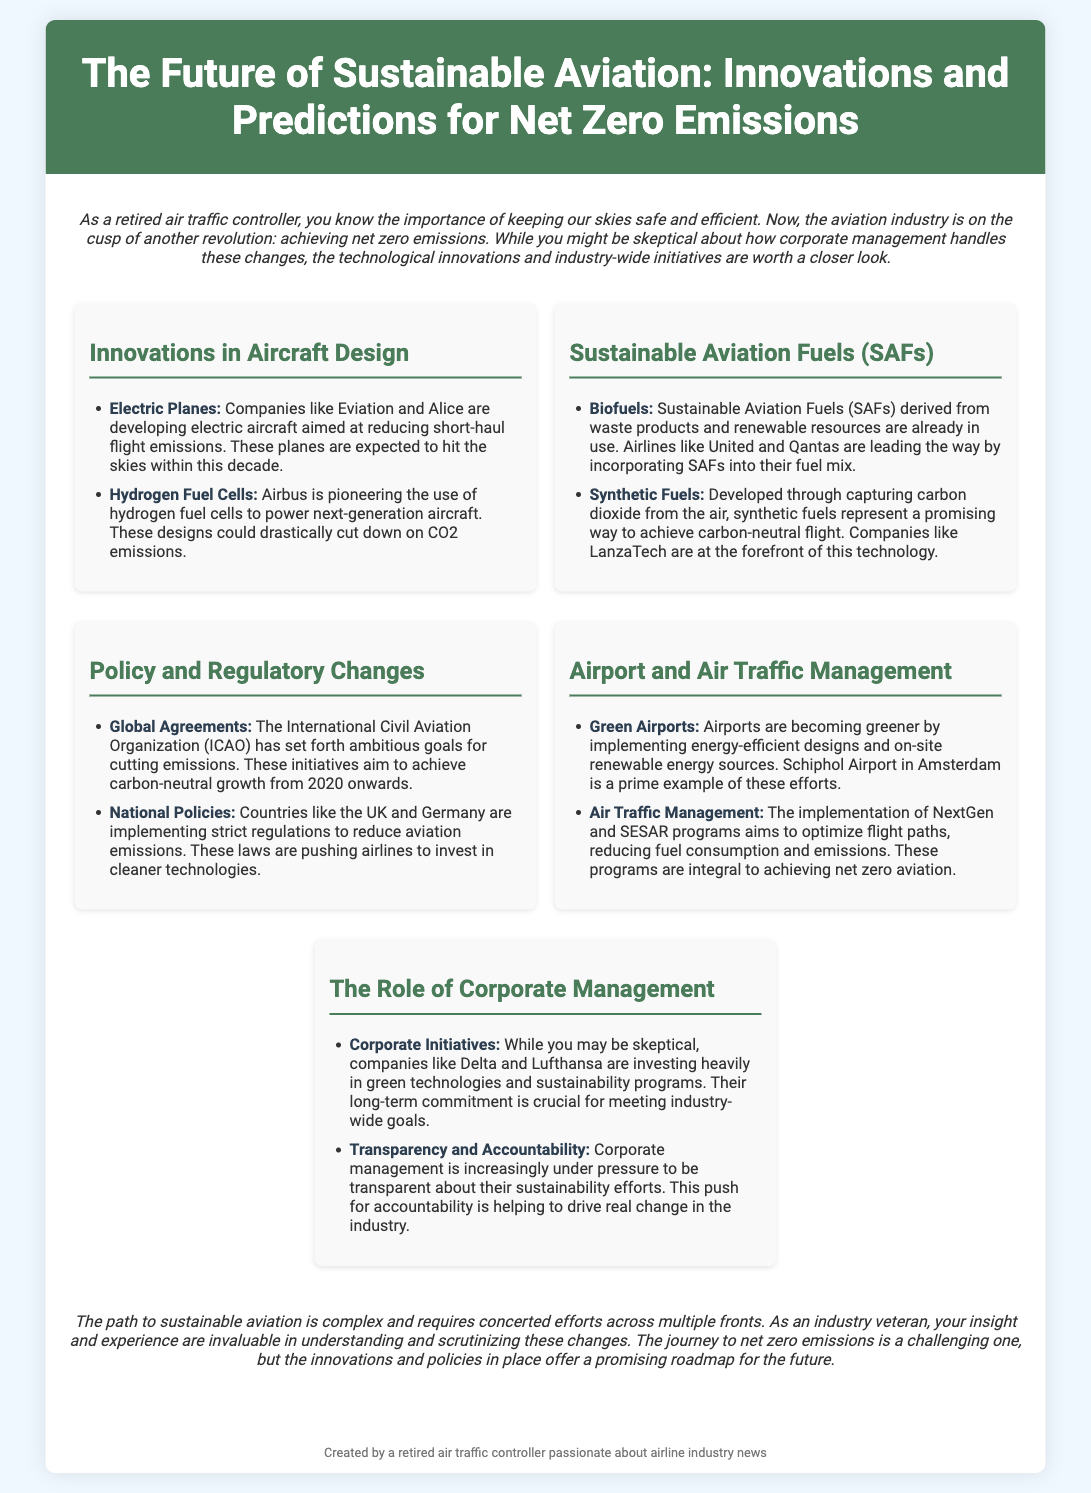What companies are developing electric aircraft? The document lists Eviation and Alice as companies developing electric aircraft aimed at reducing short-haul flight emissions.
Answer: Eviation, Alice What fuels are considered Sustainable Aviation Fuels (SAFs)? The document mentions biofuels and synthetic fuels as types of Sustainable Aviation Fuels (SAFs) used in aviation.
Answer: Biofuels, synthetic fuels What is the aim of the International Civil Aviation Organization (ICAO)? The ICAO aims to achieve carbon-neutral growth from 2020 onwards according to the document.
Answer: Carbon-neutral growth from 2020 Which airport is mentioned as a prime example of green efforts? Schiphol Airport in Amsterdam is highlighted as a prime example of efforts to become greener.
Answer: Schiphol Airport What is a significant technology that Delta and Lufthansa are investing in? The companies are heavily investing in green technologies and sustainability programs according to the document.
Answer: Green technologies What trend is noted in corporate management regarding sustainability? The document states that corporate management is increasingly under pressure to be transparent about their sustainability efforts.
Answer: Transparency and accountability What does the introduction emphasize about the aviation industry? The introduction emphasizes the importance of achieving net zero emissions and mentions technological innovations and initiatives.
Answer: Achieving net zero emissions Which two specific technologies are being explored in aircraft design? Electric planes and hydrogen fuel cells are being developed as part of innovations in aircraft design.
Answer: Electric planes, hydrogen fuel cells What is a key goal of the NextGen and SESAR programs? The NextGen and SESAR programs aim to optimize flight paths to reduce fuel consumption and emissions.
Answer: Optimize flight paths 